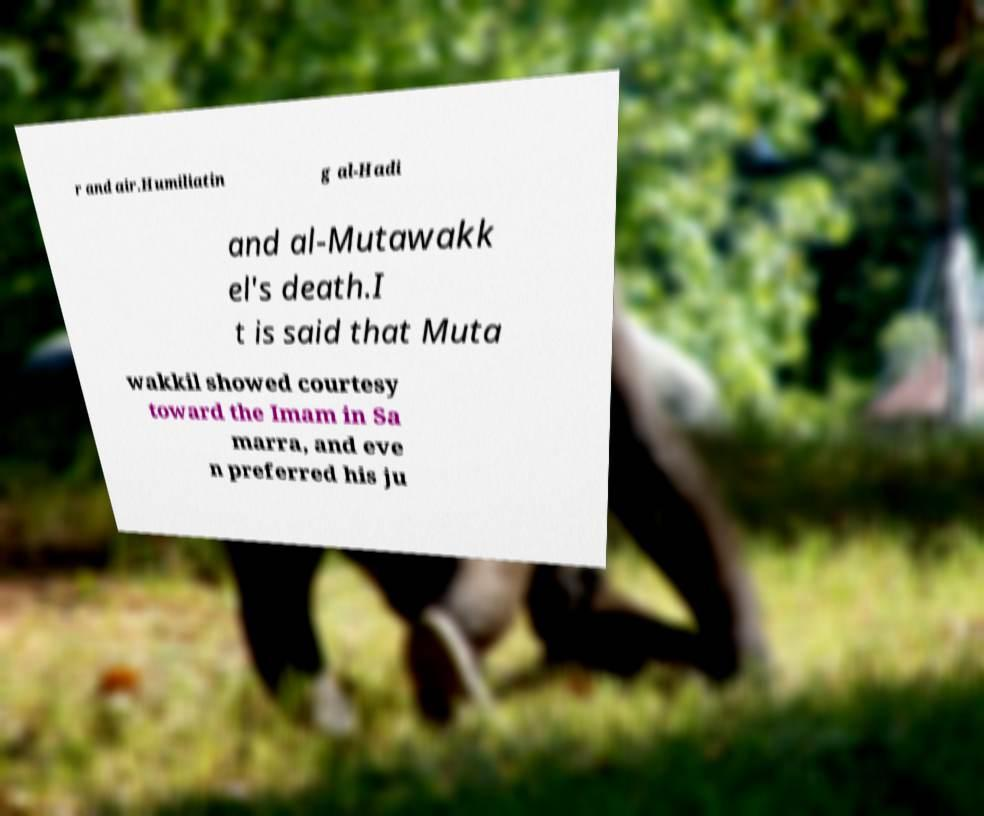Please identify and transcribe the text found in this image. r and air.Humiliatin g al-Hadi and al-Mutawakk el's death.I t is said that Muta wakkil showed courtesy toward the Imam in Sa marra, and eve n preferred his ju 